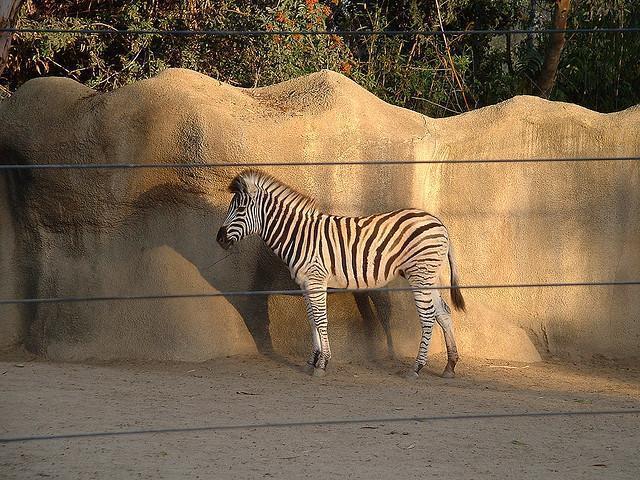How many people are in the photo?
Give a very brief answer. 0. 